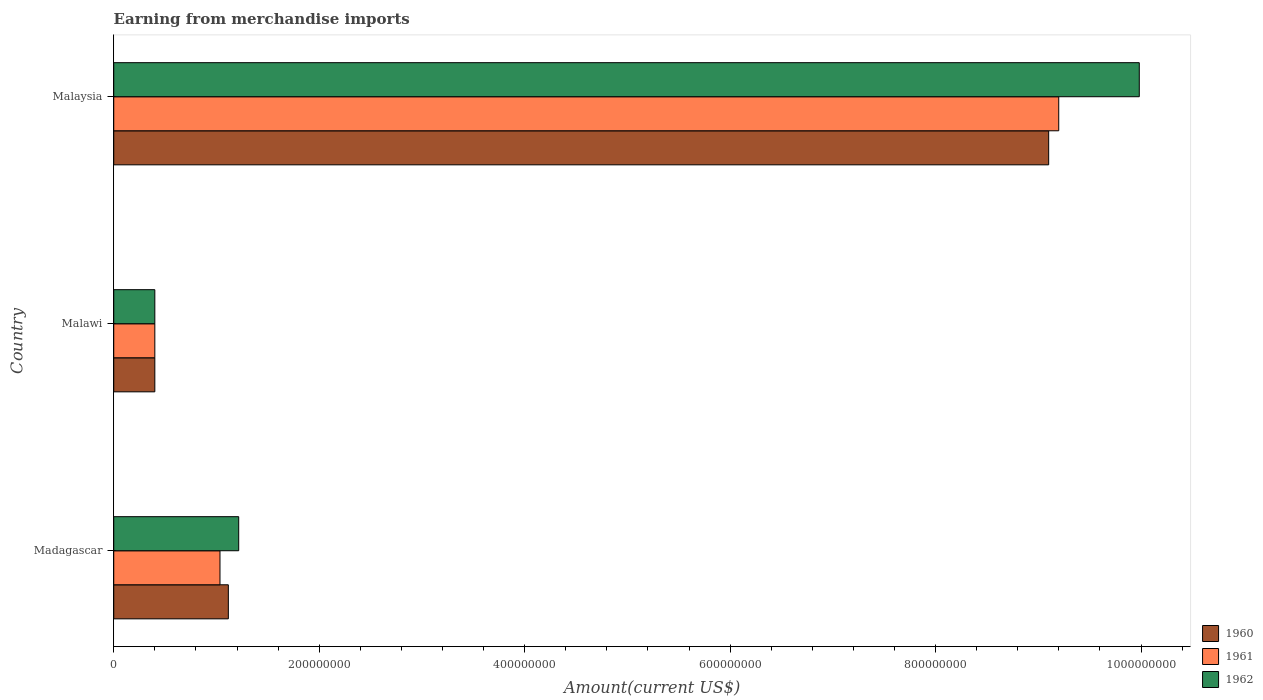How many different coloured bars are there?
Offer a terse response. 3. How many groups of bars are there?
Ensure brevity in your answer.  3. What is the label of the 1st group of bars from the top?
Offer a terse response. Malaysia. What is the amount earned from merchandise imports in 1962 in Malaysia?
Your answer should be compact. 9.98e+08. Across all countries, what is the maximum amount earned from merchandise imports in 1961?
Offer a terse response. 9.20e+08. Across all countries, what is the minimum amount earned from merchandise imports in 1961?
Ensure brevity in your answer.  4.00e+07. In which country was the amount earned from merchandise imports in 1960 maximum?
Your response must be concise. Malaysia. In which country was the amount earned from merchandise imports in 1962 minimum?
Your answer should be compact. Malawi. What is the total amount earned from merchandise imports in 1962 in the graph?
Keep it short and to the point. 1.16e+09. What is the difference between the amount earned from merchandise imports in 1961 in Madagascar and that in Malaysia?
Ensure brevity in your answer.  -8.16e+08. What is the difference between the amount earned from merchandise imports in 1960 in Malawi and the amount earned from merchandise imports in 1961 in Malaysia?
Ensure brevity in your answer.  -8.80e+08. What is the average amount earned from merchandise imports in 1961 per country?
Offer a terse response. 3.54e+08. What is the difference between the amount earned from merchandise imports in 1961 and amount earned from merchandise imports in 1960 in Malaysia?
Keep it short and to the point. 9.80e+06. In how many countries, is the amount earned from merchandise imports in 1960 greater than 760000000 US$?
Offer a terse response. 1. What is the ratio of the amount earned from merchandise imports in 1960 in Malawi to that in Malaysia?
Provide a succinct answer. 0.04. Is the difference between the amount earned from merchandise imports in 1961 in Madagascar and Malaysia greater than the difference between the amount earned from merchandise imports in 1960 in Madagascar and Malaysia?
Your answer should be very brief. No. What is the difference between the highest and the second highest amount earned from merchandise imports in 1960?
Offer a terse response. 7.99e+08. What is the difference between the highest and the lowest amount earned from merchandise imports in 1961?
Give a very brief answer. 8.80e+08. Is the sum of the amount earned from merchandise imports in 1962 in Madagascar and Malaysia greater than the maximum amount earned from merchandise imports in 1960 across all countries?
Your answer should be compact. Yes. How many bars are there?
Make the answer very short. 9. Are all the bars in the graph horizontal?
Your answer should be very brief. Yes. How many countries are there in the graph?
Offer a very short reply. 3. What is the difference between two consecutive major ticks on the X-axis?
Your answer should be very brief. 2.00e+08. Are the values on the major ticks of X-axis written in scientific E-notation?
Offer a terse response. No. Where does the legend appear in the graph?
Give a very brief answer. Bottom right. How many legend labels are there?
Offer a very short reply. 3. How are the legend labels stacked?
Provide a short and direct response. Vertical. What is the title of the graph?
Your answer should be compact. Earning from merchandise imports. What is the label or title of the X-axis?
Ensure brevity in your answer.  Amount(current US$). What is the label or title of the Y-axis?
Offer a terse response. Country. What is the Amount(current US$) in 1960 in Madagascar?
Offer a very short reply. 1.12e+08. What is the Amount(current US$) in 1961 in Madagascar?
Offer a very short reply. 1.03e+08. What is the Amount(current US$) in 1962 in Madagascar?
Provide a succinct answer. 1.22e+08. What is the Amount(current US$) of 1960 in Malawi?
Give a very brief answer. 4.00e+07. What is the Amount(current US$) of 1961 in Malawi?
Provide a succinct answer. 4.00e+07. What is the Amount(current US$) in 1962 in Malawi?
Your answer should be compact. 4.00e+07. What is the Amount(current US$) in 1960 in Malaysia?
Offer a terse response. 9.10e+08. What is the Amount(current US$) of 1961 in Malaysia?
Provide a short and direct response. 9.20e+08. What is the Amount(current US$) of 1962 in Malaysia?
Your response must be concise. 9.98e+08. Across all countries, what is the maximum Amount(current US$) in 1960?
Your answer should be compact. 9.10e+08. Across all countries, what is the maximum Amount(current US$) of 1961?
Offer a terse response. 9.20e+08. Across all countries, what is the maximum Amount(current US$) of 1962?
Your answer should be very brief. 9.98e+08. Across all countries, what is the minimum Amount(current US$) of 1960?
Make the answer very short. 4.00e+07. Across all countries, what is the minimum Amount(current US$) in 1961?
Provide a succinct answer. 4.00e+07. Across all countries, what is the minimum Amount(current US$) in 1962?
Your response must be concise. 4.00e+07. What is the total Amount(current US$) in 1960 in the graph?
Provide a succinct answer. 1.06e+09. What is the total Amount(current US$) of 1961 in the graph?
Give a very brief answer. 1.06e+09. What is the total Amount(current US$) of 1962 in the graph?
Your answer should be compact. 1.16e+09. What is the difference between the Amount(current US$) of 1960 in Madagascar and that in Malawi?
Your answer should be compact. 7.16e+07. What is the difference between the Amount(current US$) in 1961 in Madagascar and that in Malawi?
Give a very brief answer. 6.34e+07. What is the difference between the Amount(current US$) in 1962 in Madagascar and that in Malawi?
Offer a very short reply. 8.16e+07. What is the difference between the Amount(current US$) of 1960 in Madagascar and that in Malaysia?
Your answer should be compact. -7.99e+08. What is the difference between the Amount(current US$) of 1961 in Madagascar and that in Malaysia?
Your answer should be very brief. -8.16e+08. What is the difference between the Amount(current US$) in 1962 in Madagascar and that in Malaysia?
Your response must be concise. -8.77e+08. What is the difference between the Amount(current US$) in 1960 in Malawi and that in Malaysia?
Give a very brief answer. -8.70e+08. What is the difference between the Amount(current US$) in 1961 in Malawi and that in Malaysia?
Offer a very short reply. -8.80e+08. What is the difference between the Amount(current US$) in 1962 in Malawi and that in Malaysia?
Offer a terse response. -9.58e+08. What is the difference between the Amount(current US$) in 1960 in Madagascar and the Amount(current US$) in 1961 in Malawi?
Provide a short and direct response. 7.16e+07. What is the difference between the Amount(current US$) in 1960 in Madagascar and the Amount(current US$) in 1962 in Malawi?
Your answer should be very brief. 7.16e+07. What is the difference between the Amount(current US$) in 1961 in Madagascar and the Amount(current US$) in 1962 in Malawi?
Ensure brevity in your answer.  6.34e+07. What is the difference between the Amount(current US$) in 1960 in Madagascar and the Amount(current US$) in 1961 in Malaysia?
Give a very brief answer. -8.08e+08. What is the difference between the Amount(current US$) in 1960 in Madagascar and the Amount(current US$) in 1962 in Malaysia?
Offer a very short reply. -8.87e+08. What is the difference between the Amount(current US$) of 1961 in Madagascar and the Amount(current US$) of 1962 in Malaysia?
Offer a very short reply. -8.95e+08. What is the difference between the Amount(current US$) of 1960 in Malawi and the Amount(current US$) of 1961 in Malaysia?
Provide a short and direct response. -8.80e+08. What is the difference between the Amount(current US$) of 1960 in Malawi and the Amount(current US$) of 1962 in Malaysia?
Give a very brief answer. -9.58e+08. What is the difference between the Amount(current US$) in 1961 in Malawi and the Amount(current US$) in 1962 in Malaysia?
Keep it short and to the point. -9.58e+08. What is the average Amount(current US$) of 1960 per country?
Keep it short and to the point. 3.54e+08. What is the average Amount(current US$) of 1961 per country?
Ensure brevity in your answer.  3.54e+08. What is the average Amount(current US$) of 1962 per country?
Your response must be concise. 3.87e+08. What is the difference between the Amount(current US$) of 1960 and Amount(current US$) of 1961 in Madagascar?
Make the answer very short. 8.13e+06. What is the difference between the Amount(current US$) in 1960 and Amount(current US$) in 1962 in Madagascar?
Make the answer very short. -1.01e+07. What is the difference between the Amount(current US$) in 1961 and Amount(current US$) in 1962 in Madagascar?
Make the answer very short. -1.82e+07. What is the difference between the Amount(current US$) in 1960 and Amount(current US$) in 1962 in Malawi?
Provide a succinct answer. 0. What is the difference between the Amount(current US$) in 1960 and Amount(current US$) in 1961 in Malaysia?
Your response must be concise. -9.80e+06. What is the difference between the Amount(current US$) in 1960 and Amount(current US$) in 1962 in Malaysia?
Provide a short and direct response. -8.82e+07. What is the difference between the Amount(current US$) in 1961 and Amount(current US$) in 1962 in Malaysia?
Make the answer very short. -7.84e+07. What is the ratio of the Amount(current US$) in 1960 in Madagascar to that in Malawi?
Offer a very short reply. 2.79. What is the ratio of the Amount(current US$) in 1961 in Madagascar to that in Malawi?
Provide a short and direct response. 2.59. What is the ratio of the Amount(current US$) of 1962 in Madagascar to that in Malawi?
Provide a succinct answer. 3.04. What is the ratio of the Amount(current US$) of 1960 in Madagascar to that in Malaysia?
Your answer should be very brief. 0.12. What is the ratio of the Amount(current US$) in 1961 in Madagascar to that in Malaysia?
Provide a succinct answer. 0.11. What is the ratio of the Amount(current US$) in 1962 in Madagascar to that in Malaysia?
Your answer should be very brief. 0.12. What is the ratio of the Amount(current US$) in 1960 in Malawi to that in Malaysia?
Provide a succinct answer. 0.04. What is the ratio of the Amount(current US$) in 1961 in Malawi to that in Malaysia?
Ensure brevity in your answer.  0.04. What is the ratio of the Amount(current US$) of 1962 in Malawi to that in Malaysia?
Your answer should be compact. 0.04. What is the difference between the highest and the second highest Amount(current US$) in 1960?
Provide a succinct answer. 7.99e+08. What is the difference between the highest and the second highest Amount(current US$) of 1961?
Your answer should be compact. 8.16e+08. What is the difference between the highest and the second highest Amount(current US$) of 1962?
Your answer should be very brief. 8.77e+08. What is the difference between the highest and the lowest Amount(current US$) of 1960?
Offer a very short reply. 8.70e+08. What is the difference between the highest and the lowest Amount(current US$) of 1961?
Ensure brevity in your answer.  8.80e+08. What is the difference between the highest and the lowest Amount(current US$) in 1962?
Ensure brevity in your answer.  9.58e+08. 